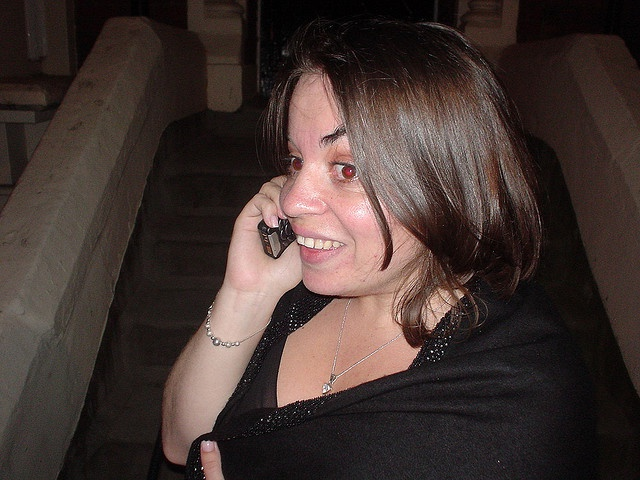Describe the objects in this image and their specific colors. I can see people in black, lightpink, and gray tones and cell phone in black, gray, and darkgray tones in this image. 